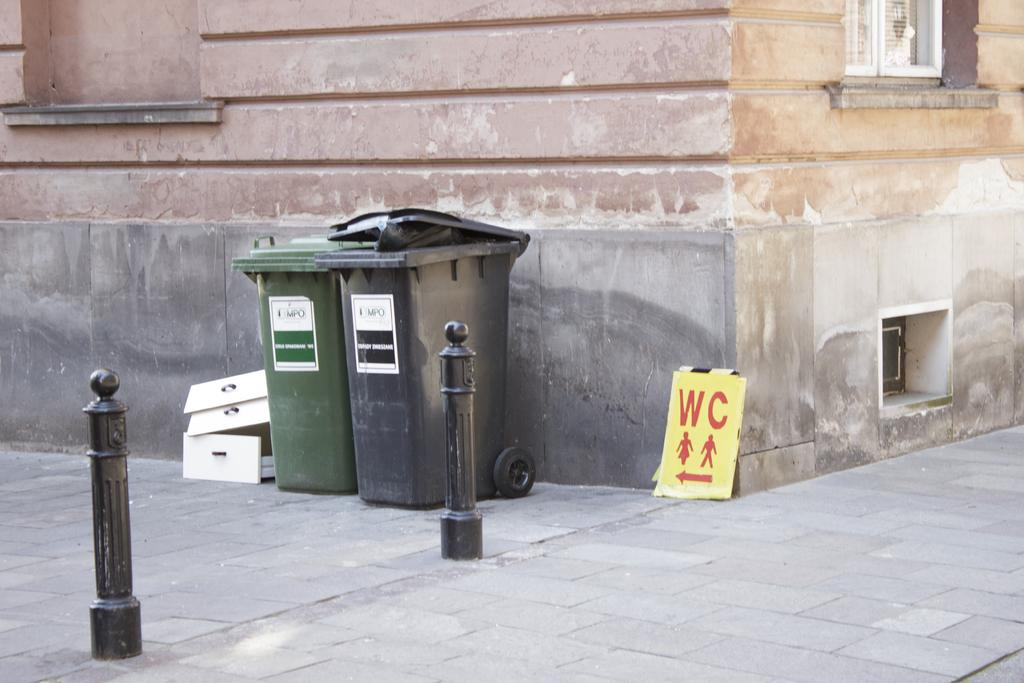<image>
Share a concise interpretation of the image provided. A yellow and red WC sign leans against the outside of a building. 